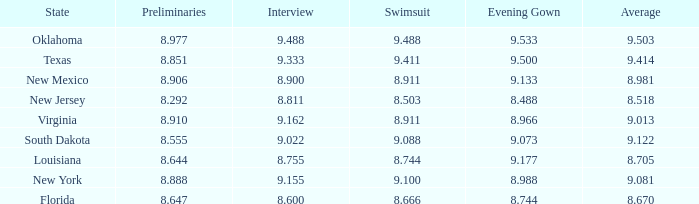 what's the preliminaries where state is south dakota 8.555. 